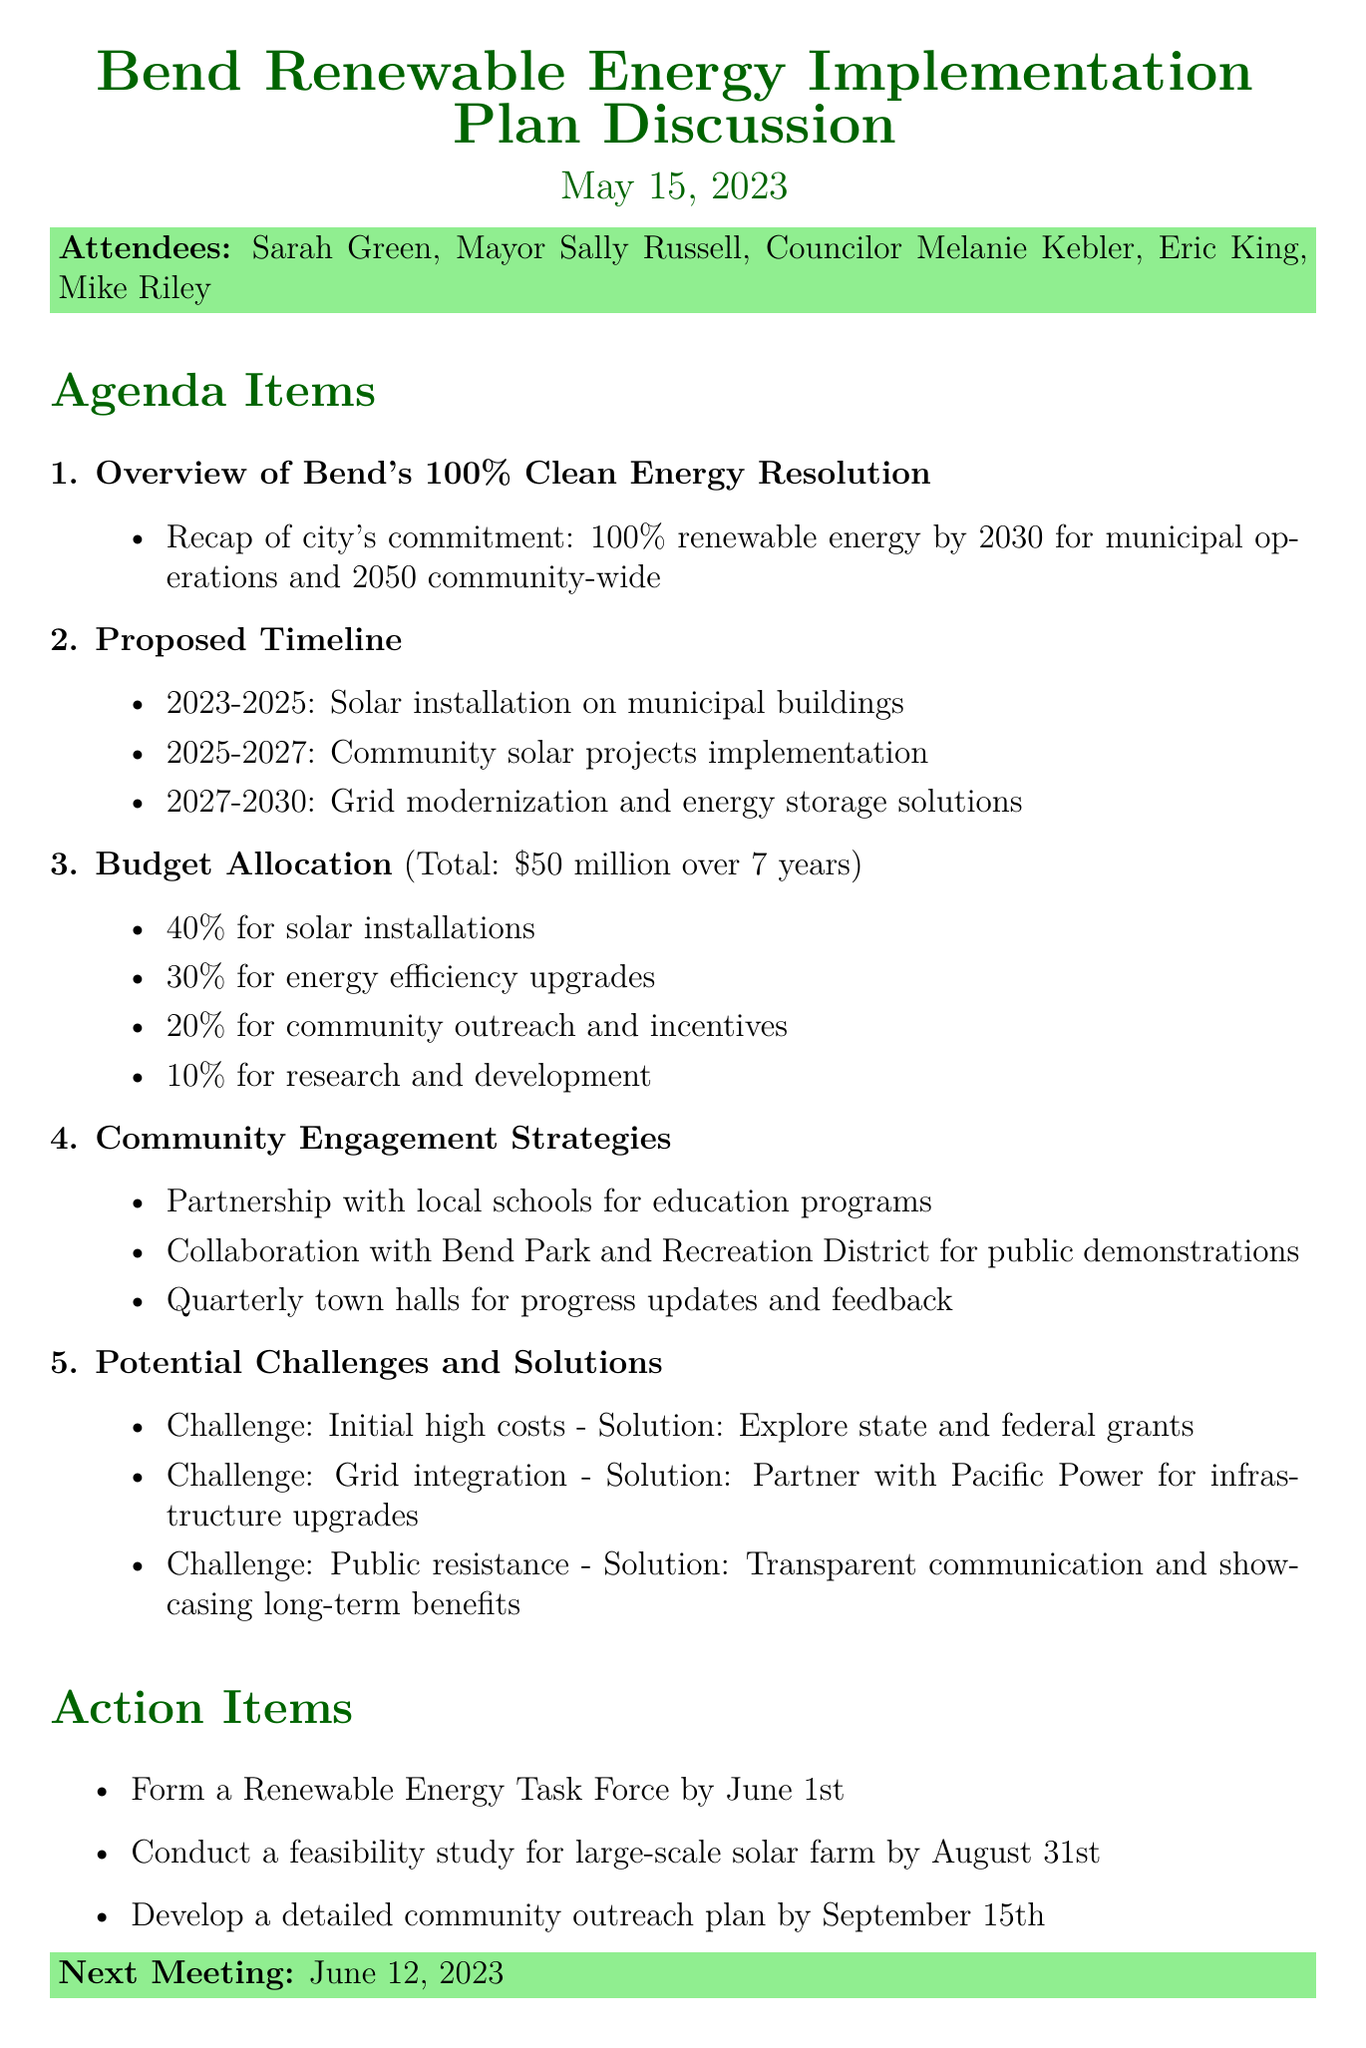what is the date of the meeting? The date of the meeting is mentioned at the top of the document.
Answer: May 15, 2023 who is the city manager mentioned in the attendees list? The attendees list includes the name of the city manager.
Answer: Eric King what is the total proposed budget for the renewable energy implementation plan? The document specifies the total proposed budget for the project.
Answer: $50 million how long will the solar installation on municipal buildings take? The proposed timeline provides the duration for solar installations.
Answer: 2023-2025 what percentage of the budget is allocated for energy efficiency upgrades? The budget allocation section details the percentage for various categories.
Answer: 30% what challenge is associated with initial high costs? The document lists some challenges alongside their solutions.
Answer: Initial high costs when is the next meeting scheduled? The next meeting date is provided in the document.
Answer: June 12, 2023 what is one of the community engagement strategies mentioned? The document describes various strategies for community engagement.
Answer: Partnership with local schools for education programs what is the proposed action item due by September 15th? The action items section outlines specific tasks and their deadlines.
Answer: Develop a detailed community outreach plan by September 15th 